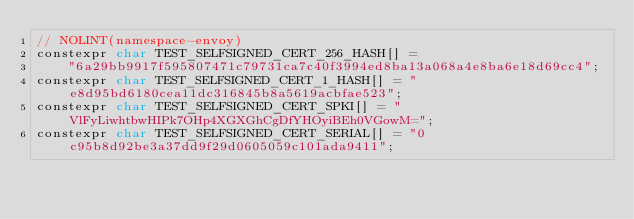<code> <loc_0><loc_0><loc_500><loc_500><_C_>// NOLINT(namespace-envoy)
constexpr char TEST_SELFSIGNED_CERT_256_HASH[] =
    "6a29bb9917f595807471c79731ca7c40f3994ed8ba13a068a4e8ba6e18d69cc4";
constexpr char TEST_SELFSIGNED_CERT_1_HASH[] = "e8d95bd6180cea11dc316845b8a5619acbfae523";
constexpr char TEST_SELFSIGNED_CERT_SPKI[] = "VlFyLiwhtbwHIPk7OHp4XGXGhCgDfYHOyiBEh0VGowM=";
constexpr char TEST_SELFSIGNED_CERT_SERIAL[] = "0c95b8d92be3a37dd9f29d0605059c101ada9411";</code> 